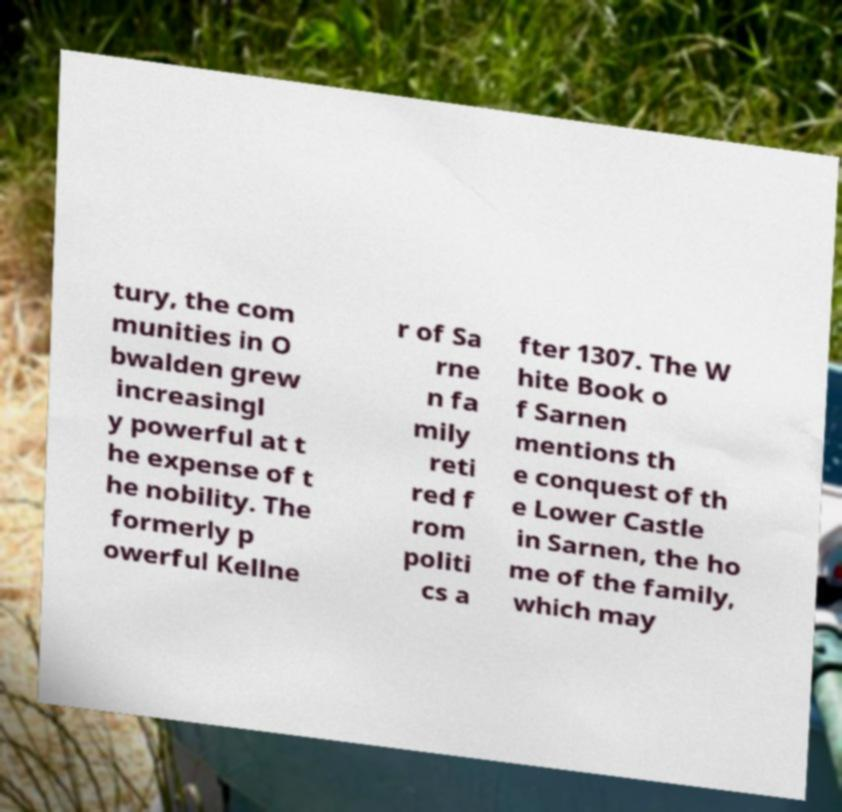Can you accurately transcribe the text from the provided image for me? tury, the com munities in O bwalden grew increasingl y powerful at t he expense of t he nobility. The formerly p owerful Kellne r of Sa rne n fa mily reti red f rom politi cs a fter 1307. The W hite Book o f Sarnen mentions th e conquest of th e Lower Castle in Sarnen, the ho me of the family, which may 